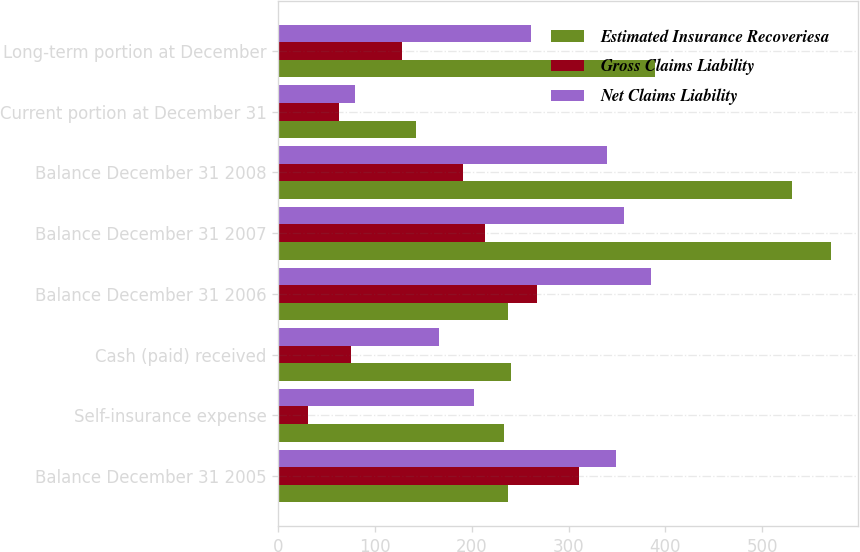Convert chart to OTSL. <chart><loc_0><loc_0><loc_500><loc_500><stacked_bar_chart><ecel><fcel>Balance December 31 2005<fcel>Self-insurance expense<fcel>Cash (paid) received<fcel>Balance December 31 2006<fcel>Balance December 31 2007<fcel>Balance December 31 2008<fcel>Current portion at December 31<fcel>Long-term portion at December<nl><fcel>Estimated Insurance Recoveriesa<fcel>237<fcel>233<fcel>241<fcel>237<fcel>571<fcel>531<fcel>142<fcel>389<nl><fcel>Gross Claims Liability<fcel>311<fcel>31<fcel>75<fcel>267<fcel>214<fcel>191<fcel>63<fcel>128<nl><fcel>Net Claims Liability<fcel>349<fcel>202<fcel>166<fcel>385<fcel>357<fcel>340<fcel>79<fcel>261<nl></chart> 